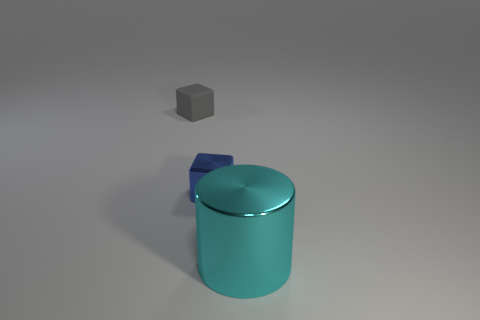Is there any other thing that is the same size as the cyan cylinder?
Your response must be concise. No. What number of other things are there of the same material as the gray thing
Offer a very short reply. 0. There is a gray cube that is the same size as the blue cube; what is its material?
Provide a short and direct response. Rubber. Is there a blue object of the same shape as the cyan thing?
Offer a terse response. No. How many cubes have the same color as the shiny cylinder?
Provide a succinct answer. 0. There is a object in front of the blue shiny thing; what is its size?
Your response must be concise. Large. What number of blue metal blocks are the same size as the cyan object?
Your answer should be very brief. 0. There is a small block that is the same material as the big object; what color is it?
Keep it short and to the point. Blue. Are there fewer blocks in front of the large cyan cylinder than tiny yellow matte cylinders?
Ensure brevity in your answer.  No. There is another thing that is made of the same material as the cyan object; what shape is it?
Offer a very short reply. Cube. 